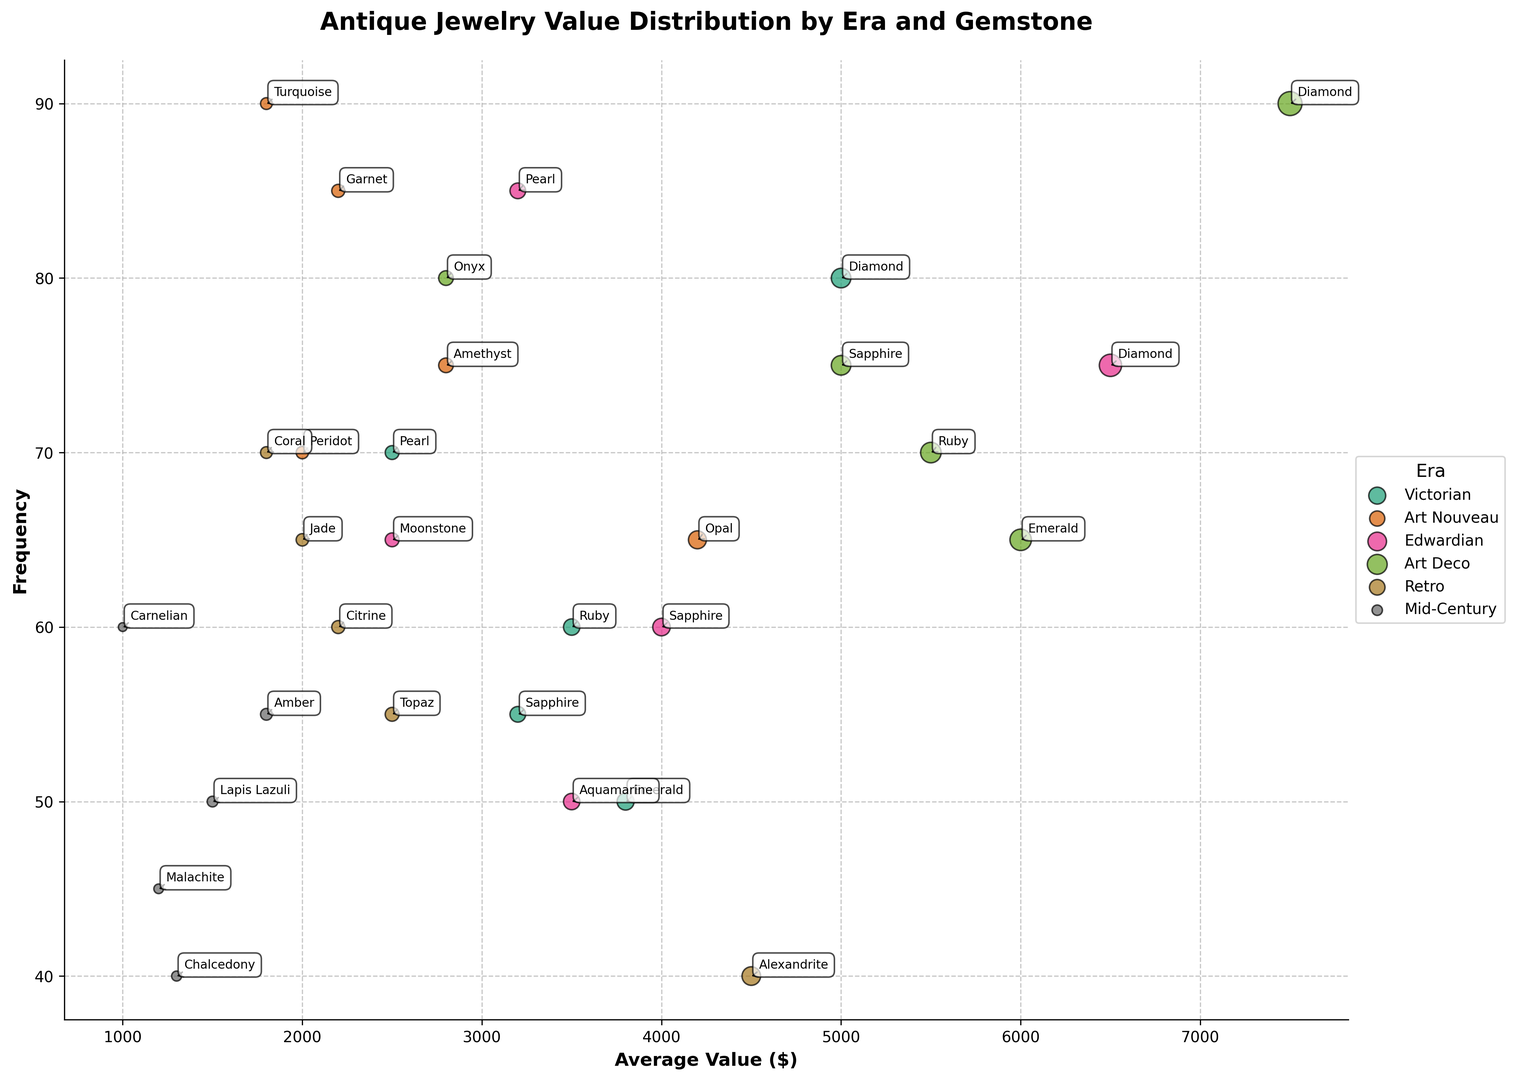Which gemstone in the Art Deco era has the highest average value? By looking at the data points for the Art Deco era in the figure, identify which gemstone has the largest average value. The diamond has the highest position in the vertical scale among Art Deco gemstones indicating the highest average value.
Answer: Diamond How does the frequency of Victorian sapphires compare to Edwardian sapphires? Identify and compare the positions of Victorian sapphires and Edwardian sapphires on the frequency axis. The frequency of Victorian sapphires (55) is less than that of Edwardian sapphires (60).
Answer: Victorian sapphires have a lower frequency Which era has the highest concentration of gemstones with average values above $5000? Examine the areas where the average values are plotted above $5000 on the x-axis and note which era appears most frequently. Art Deco has multiple gemstones above $5000, including Diamond, Ruby, and Emerald.
Answer: Art Deco What is the combined frequency of all gemstones in the Retro era? Sum the frequencies of all the gemstones listed under the Retro era: Citrine (60), Topaz (55), Alexandrite (40), Coral (70), and Jade (65). The combined frequency is 60 + 55 + 40 + 70 + 65.
Answer: 290 Compare the average value of Art Nouveau Opal to Edwardian Aquamarine. Which is higher and by how much? Check the average values of Art Nouveau Opal ($4200) and Edwardian Aquamarine ($3500), then calculate the difference: $4200 - $3500.
Answer: Opal is higher by $700 Which gemstone has the highest average value across all eras? Look for the highest position on the average value axis, regardless of era. The highest plotted point is for Art Deco Diamond, which has an average value of $7500.
Answer: Art Deco Diamond What is the frequency difference between Victorian Diamonds and Art Deco Diamonds? Subtract the frequency of Art Deco Diamonds (90) from Victorian Diamonds (80): 90 - 80.
Answer: 10 Identify the gemstone with the lowest average value in the Mid-Century era. Find the lowest average value in the Mid-Century era, which would be the point furthest to the left. Chalcedony has the lowest average value at $1300.
Answer: Chalcedony 